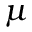<formula> <loc_0><loc_0><loc_500><loc_500>\mu</formula> 